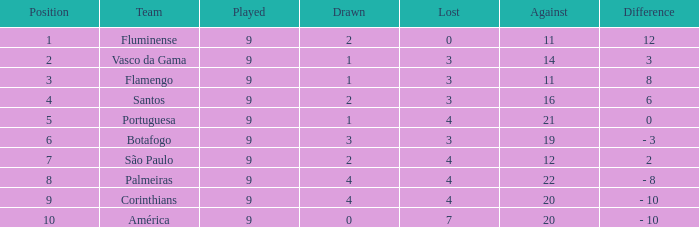Which opposite is the greatest one that has a disparity of 12? 11.0. Write the full table. {'header': ['Position', 'Team', 'Played', 'Drawn', 'Lost', 'Against', 'Difference'], 'rows': [['1', 'Fluminense', '9', '2', '0', '11', '12'], ['2', 'Vasco da Gama', '9', '1', '3', '14', '3'], ['3', 'Flamengo', '9', '1', '3', '11', '8'], ['4', 'Santos', '9', '2', '3', '16', '6'], ['5', 'Portuguesa', '9', '1', '4', '21', '0'], ['6', 'Botafogo', '9', '3', '3', '19', '- 3'], ['7', 'São Paulo', '9', '2', '4', '12', '2'], ['8', 'Palmeiras', '9', '4', '4', '22', '- 8'], ['9', 'Corinthians', '9', '4', '4', '20', '- 10'], ['10', 'América', '9', '0', '7', '20', '- 10']]} 